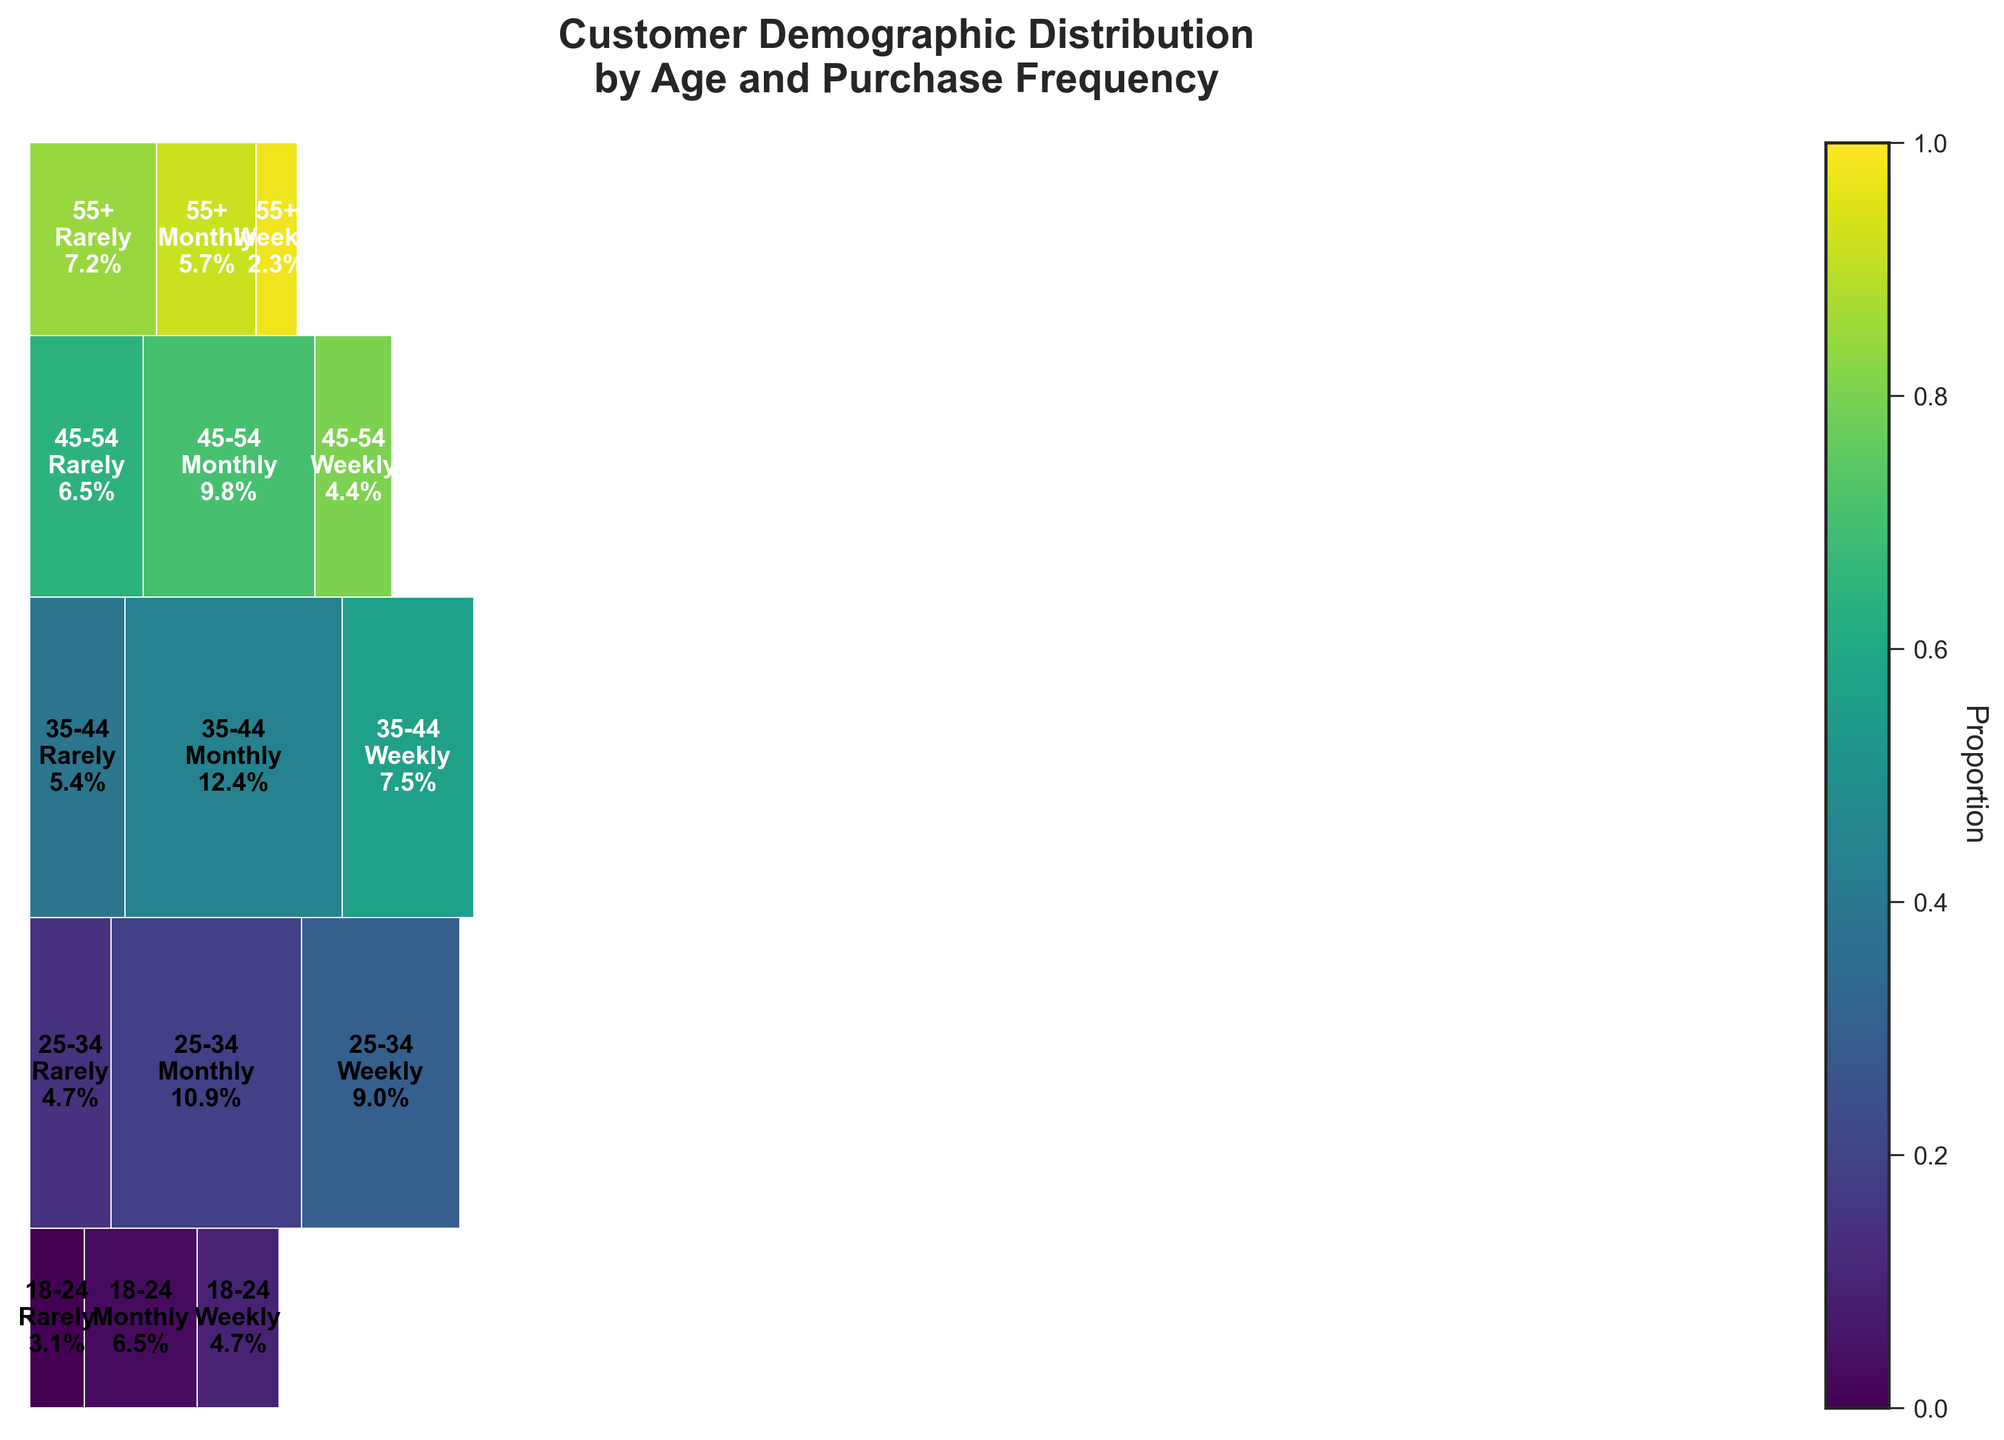What is the title of the mosaic plot? The title is bold and positioned at the top of the figure, reading "Customer Demographic Distribution by Age and Purchase Frequency".
Answer: Customer Demographic Distribution by Age and Purchase Frequency Which age group has the highest proportion of monthly purchases? In the plot's central composition, the height and width together indicate the proportion. The biggest rectangle in the "Monthly" sector belongs to "35-44" age group.
Answer: 35-44 How much higher is the percentage of weekly purchases for 25-34 age group compared to 18-24 age group? The percentages are provided within the plot. For weekly purchases, 25-34 shows 14.1% and 18-24 shows 7.0%, a difference of 14.1% - 7.0% = 7.1%.
Answer: 7.1% Which age group shows the highest proportion of "Rarely" purchases? By evaluating the size of the rectangles in the "Rarely" section, the tallest one represents "55+" age group.
Answer: 55+ What is the sum of the percentages of monthly and weekly purchases for the 18-24 age group? The plot provides specific percentages for each category within the age group. Adding Monthly (17.5%) and Weekly (12.6%) yields 17.5% + 12.6% = 30.1%.
Answer: 30.1% Which age group displays the smallest proportion of weekly purchases, and what is that percentage? The plot's rectangles in the "Weekly" sector reveal the smallest one in the "55+" age group, marked as 3.2%.
Answer: 55+, 3.2% Among all age groups, which purchase frequency category occupies the largest area in the plot and which group holds it? The most visually dominant rectangle, considering both width and height, is in the "Monthly" category within the "35-44" age group.
Answer: Monthly, 35-44 How does the proportion of rarely purchases for 45-54 compare to that of 35-44 age group? Observing the rectangle sizes in the "Rarely" section, the 45-54 group appears larger than the 35-44 group.
Answer: 45-54 > 35-44 